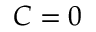Convert formula to latex. <formula><loc_0><loc_0><loc_500><loc_500>C = 0</formula> 